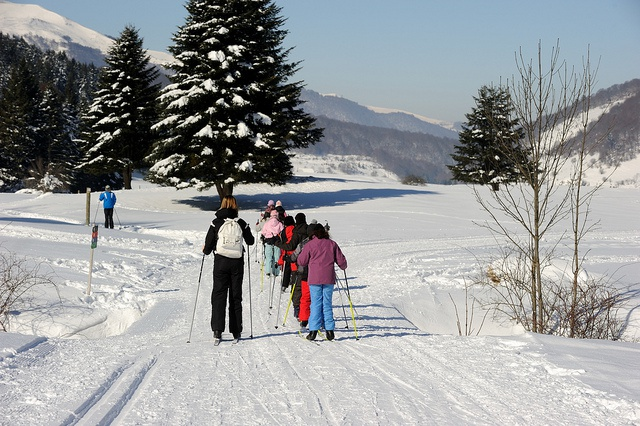Describe the objects in this image and their specific colors. I can see people in darkgray, purple, black, and lightblue tones, backpack in darkgray, beige, black, and lightgray tones, people in darkgray, black, red, and gray tones, people in darkgray, black, pink, and lightpink tones, and people in darkgray, red, black, gray, and brown tones in this image. 